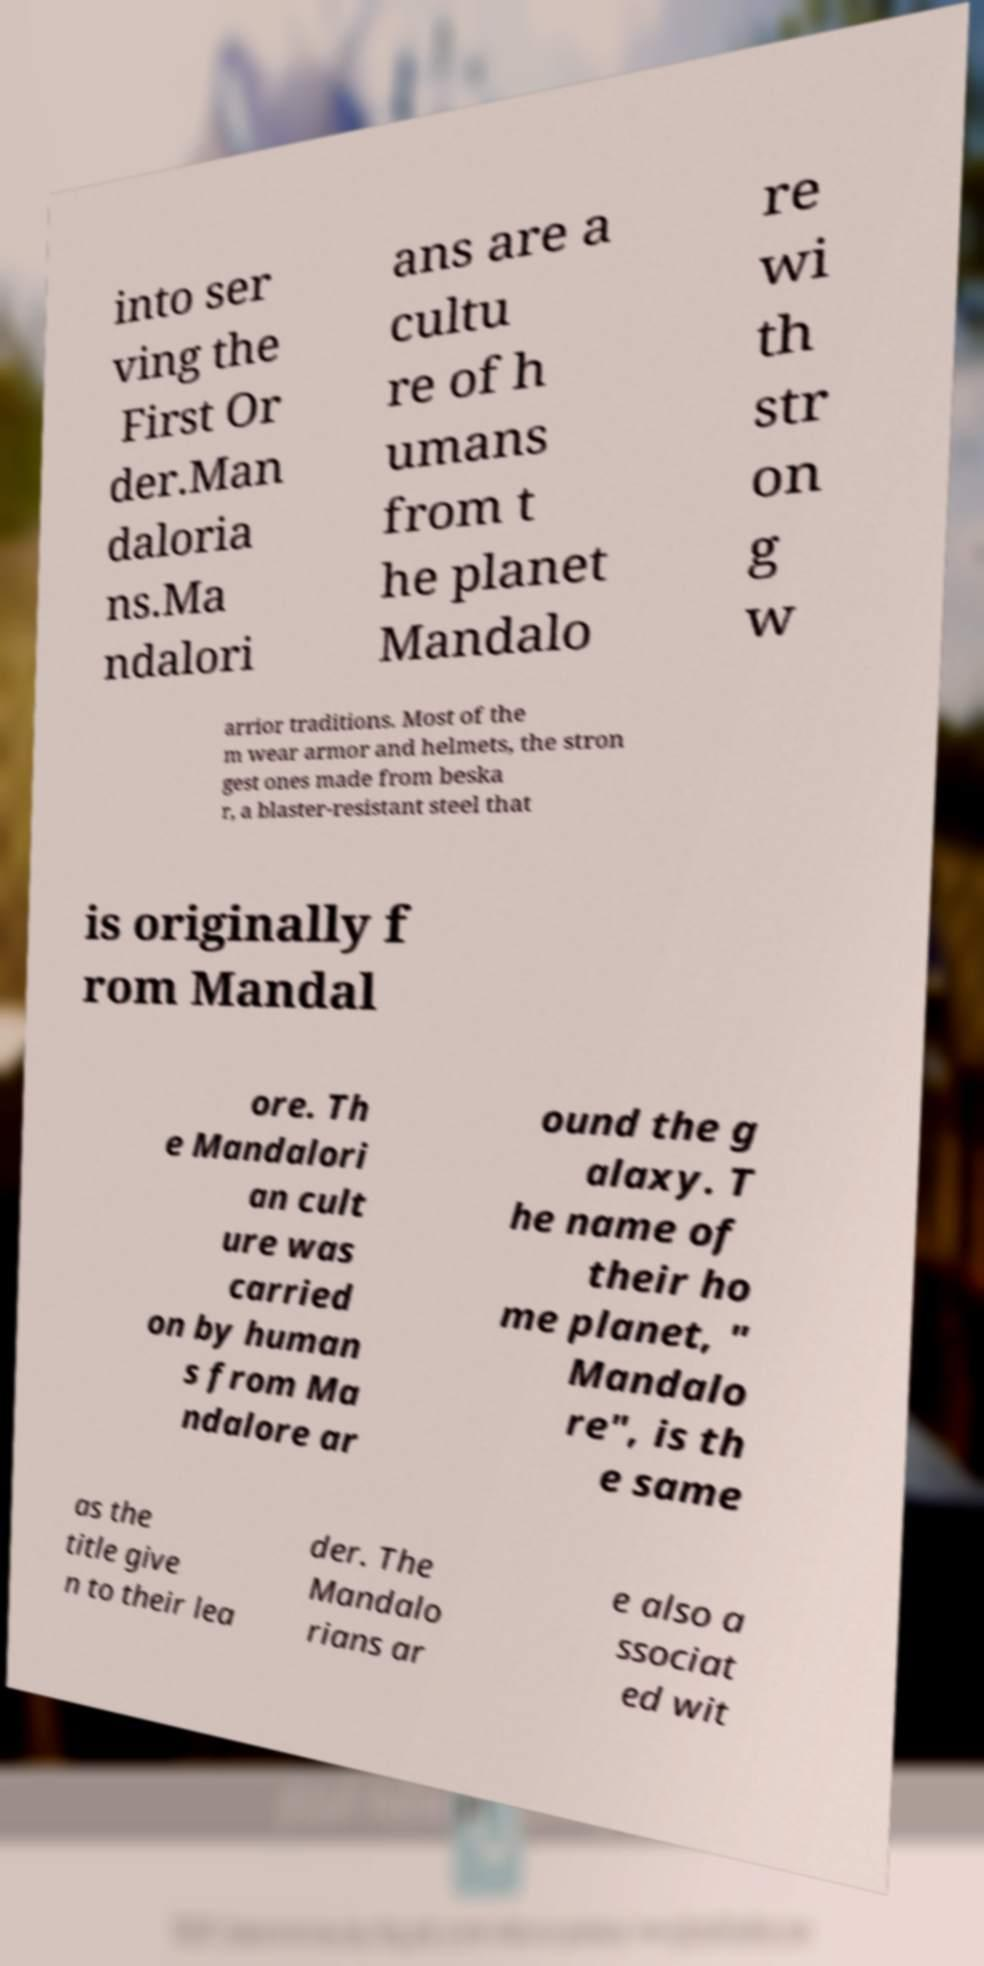Please read and relay the text visible in this image. What does it say? into ser ving the First Or der.Man daloria ns.Ma ndalori ans are a cultu re of h umans from t he planet Mandalo re wi th str on g w arrior traditions. Most of the m wear armor and helmets, the stron gest ones made from beska r, a blaster-resistant steel that is originally f rom Mandal ore. Th e Mandalori an cult ure was carried on by human s from Ma ndalore ar ound the g alaxy. T he name of their ho me planet, " Mandalo re", is th e same as the title give n to their lea der. The Mandalo rians ar e also a ssociat ed wit 